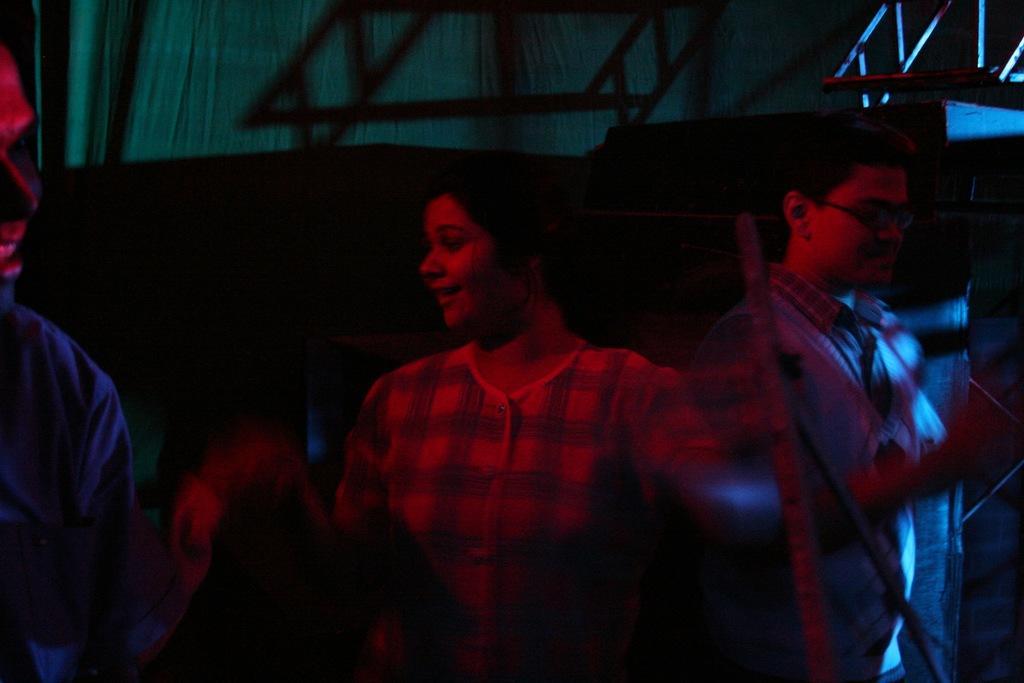Please provide a concise description of this image. In this image in front there are three persons standing on the floor. On the backside there are curtains and a few other objects. 